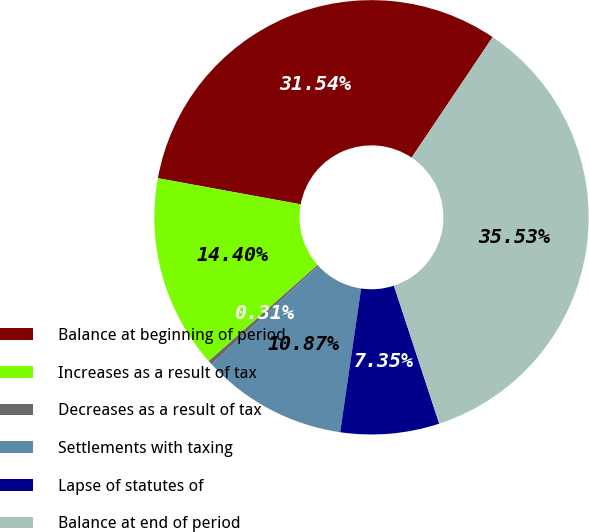<chart> <loc_0><loc_0><loc_500><loc_500><pie_chart><fcel>Balance at beginning of period<fcel>Increases as a result of tax<fcel>Decreases as a result of tax<fcel>Settlements with taxing<fcel>Lapse of statutes of<fcel>Balance at end of period<nl><fcel>31.54%<fcel>14.4%<fcel>0.31%<fcel>10.87%<fcel>7.35%<fcel>35.53%<nl></chart> 